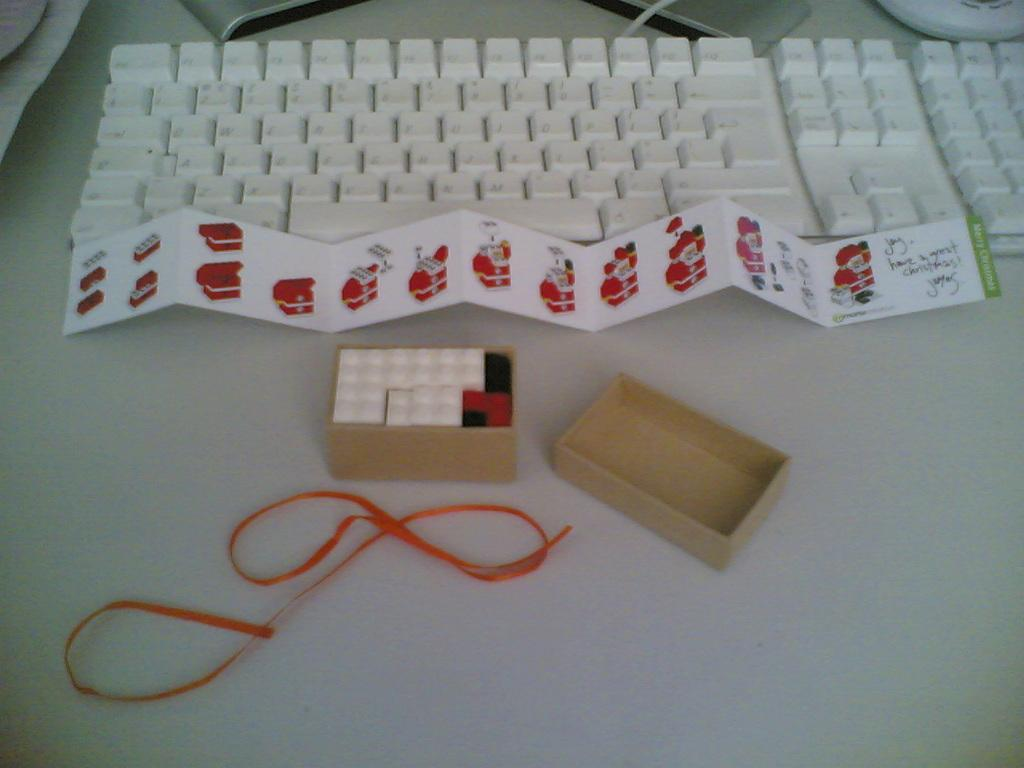What type of device is visible in the image? There is a keyboard in the image. What is the paper used for in the image? The purpose of the paper in the image is not specified, but it is present. What is the monitor stand used for in the image? The monitor stand is used to hold a monitor, although the monitor itself is not visible in the image. What is the thread used for in the image? The purpose of the thread in the image is not specified, but it is present. What is the box used for in the image? The purpose of the box in the image is not specified, but it is present. On what surface are all these objects placed? All these objects are placed on a table. What type of playground equipment can be seen in the image? There is no playground equipment present in the image. What disease is being treated in the image? There is no indication of any disease or medical treatment in the image. 